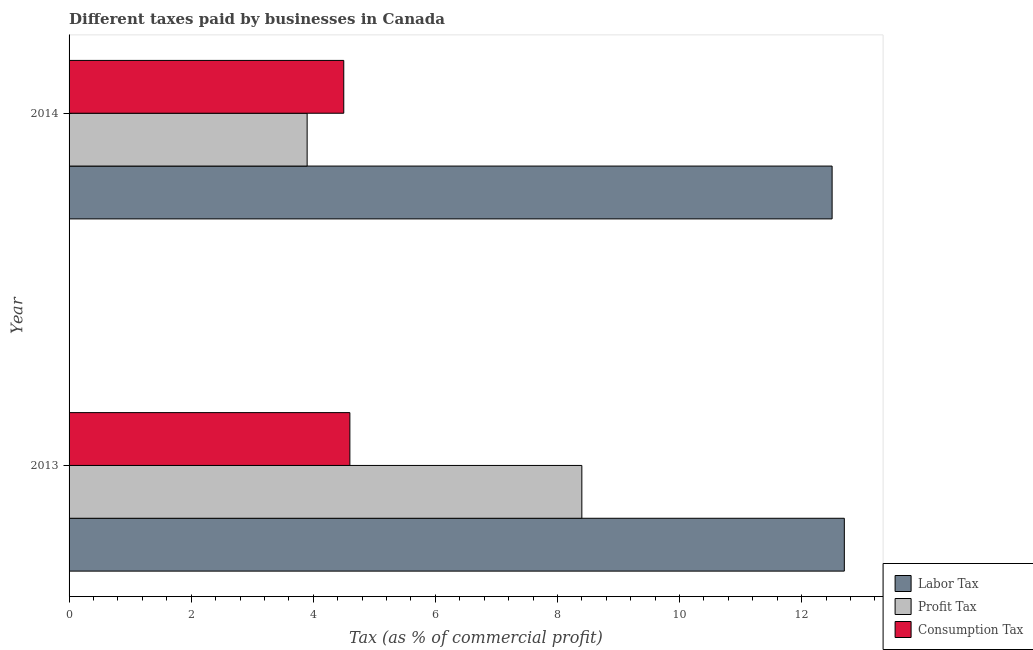How many different coloured bars are there?
Offer a terse response. 3. Are the number of bars per tick equal to the number of legend labels?
Your answer should be very brief. Yes. Are the number of bars on each tick of the Y-axis equal?
Your response must be concise. Yes. How many bars are there on the 2nd tick from the top?
Give a very brief answer. 3. How many bars are there on the 2nd tick from the bottom?
Your response must be concise. 3. In how many cases, is the number of bars for a given year not equal to the number of legend labels?
Offer a very short reply. 0. What is the percentage of labor tax in 2014?
Your answer should be compact. 12.5. Across all years, what is the maximum percentage of consumption tax?
Provide a succinct answer. 4.6. In which year was the percentage of consumption tax maximum?
Make the answer very short. 2013. What is the total percentage of labor tax in the graph?
Make the answer very short. 25.2. What is the average percentage of profit tax per year?
Make the answer very short. 6.15. In how many years, is the percentage of labor tax greater than 7.6 %?
Offer a terse response. 2. What is the ratio of the percentage of profit tax in 2013 to that in 2014?
Offer a very short reply. 2.15. What does the 3rd bar from the top in 2013 represents?
Keep it short and to the point. Labor Tax. What does the 3rd bar from the bottom in 2014 represents?
Offer a terse response. Consumption Tax. How many bars are there?
Offer a terse response. 6. Are all the bars in the graph horizontal?
Keep it short and to the point. Yes. How many years are there in the graph?
Ensure brevity in your answer.  2. Are the values on the major ticks of X-axis written in scientific E-notation?
Your response must be concise. No. Does the graph contain any zero values?
Make the answer very short. No. How many legend labels are there?
Provide a succinct answer. 3. How are the legend labels stacked?
Provide a succinct answer. Vertical. What is the title of the graph?
Give a very brief answer. Different taxes paid by businesses in Canada. Does "Slovak Republic" appear as one of the legend labels in the graph?
Offer a terse response. No. What is the label or title of the X-axis?
Your answer should be very brief. Tax (as % of commercial profit). What is the label or title of the Y-axis?
Your answer should be compact. Year. What is the Tax (as % of commercial profit) in Consumption Tax in 2013?
Offer a very short reply. 4.6. What is the Tax (as % of commercial profit) in Labor Tax in 2014?
Provide a succinct answer. 12.5. What is the Tax (as % of commercial profit) of Profit Tax in 2014?
Provide a succinct answer. 3.9. What is the Tax (as % of commercial profit) in Consumption Tax in 2014?
Offer a very short reply. 4.5. Across all years, what is the maximum Tax (as % of commercial profit) of Consumption Tax?
Offer a very short reply. 4.6. Across all years, what is the minimum Tax (as % of commercial profit) of Labor Tax?
Make the answer very short. 12.5. Across all years, what is the minimum Tax (as % of commercial profit) of Profit Tax?
Offer a terse response. 3.9. What is the total Tax (as % of commercial profit) in Labor Tax in the graph?
Provide a succinct answer. 25.2. What is the total Tax (as % of commercial profit) in Profit Tax in the graph?
Your response must be concise. 12.3. What is the total Tax (as % of commercial profit) in Consumption Tax in the graph?
Ensure brevity in your answer.  9.1. What is the difference between the Tax (as % of commercial profit) in Labor Tax in 2013 and that in 2014?
Make the answer very short. 0.2. What is the difference between the Tax (as % of commercial profit) in Consumption Tax in 2013 and that in 2014?
Your answer should be very brief. 0.1. What is the difference between the Tax (as % of commercial profit) in Labor Tax in 2013 and the Tax (as % of commercial profit) in Profit Tax in 2014?
Keep it short and to the point. 8.8. What is the average Tax (as % of commercial profit) in Profit Tax per year?
Ensure brevity in your answer.  6.15. What is the average Tax (as % of commercial profit) of Consumption Tax per year?
Offer a terse response. 4.55. In the year 2013, what is the difference between the Tax (as % of commercial profit) in Labor Tax and Tax (as % of commercial profit) in Consumption Tax?
Your answer should be very brief. 8.1. In the year 2013, what is the difference between the Tax (as % of commercial profit) of Profit Tax and Tax (as % of commercial profit) of Consumption Tax?
Provide a short and direct response. 3.8. In the year 2014, what is the difference between the Tax (as % of commercial profit) in Labor Tax and Tax (as % of commercial profit) in Consumption Tax?
Your response must be concise. 8. In the year 2014, what is the difference between the Tax (as % of commercial profit) in Profit Tax and Tax (as % of commercial profit) in Consumption Tax?
Your answer should be compact. -0.6. What is the ratio of the Tax (as % of commercial profit) of Profit Tax in 2013 to that in 2014?
Your response must be concise. 2.15. What is the ratio of the Tax (as % of commercial profit) of Consumption Tax in 2013 to that in 2014?
Provide a short and direct response. 1.02. What is the difference between the highest and the second highest Tax (as % of commercial profit) in Profit Tax?
Provide a succinct answer. 4.5. 